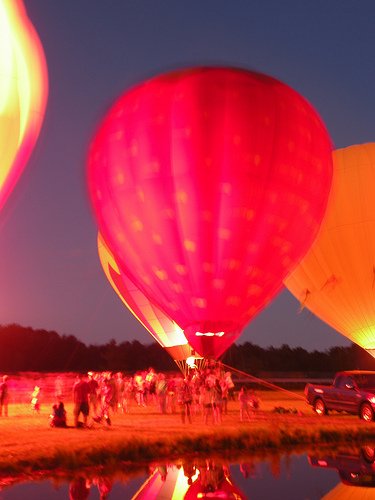<image>
Is the air balloon next to the people? Yes. The air balloon is positioned adjacent to the people, located nearby in the same general area. Where is the balloon in relation to the truck? Is it behind the truck? Yes. From this viewpoint, the balloon is positioned behind the truck, with the truck partially or fully occluding the balloon. 